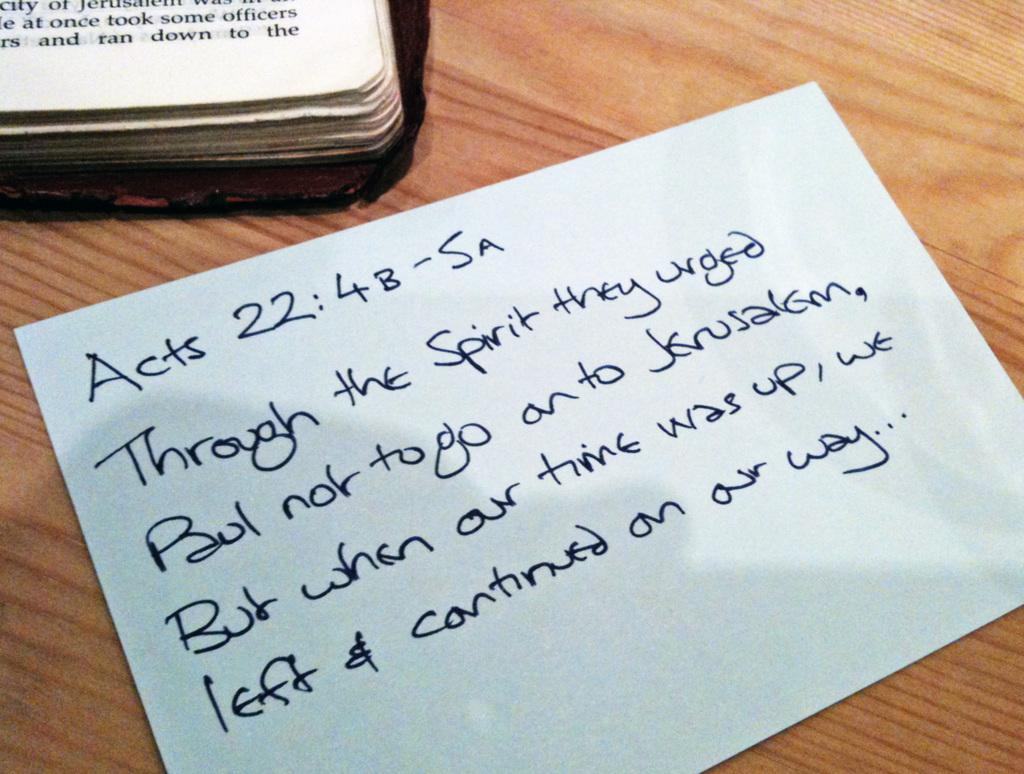Provide a one-sentence caption for the provided image. the word acts that is on a piece of paper. 